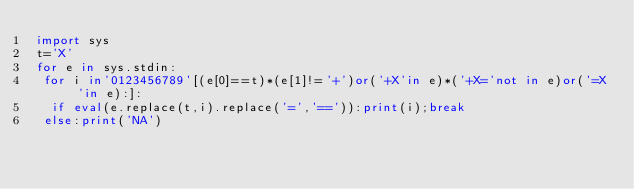Convert code to text. <code><loc_0><loc_0><loc_500><loc_500><_Python_>import sys
t='X'
for e in sys.stdin:
 for i in'0123456789'[(e[0]==t)*(e[1]!='+')or('+X'in e)*('+X='not in e)or('=X'in e):]:
  if eval(e.replace(t,i).replace('=','==')):print(i);break
 else:print('NA')
</code> 